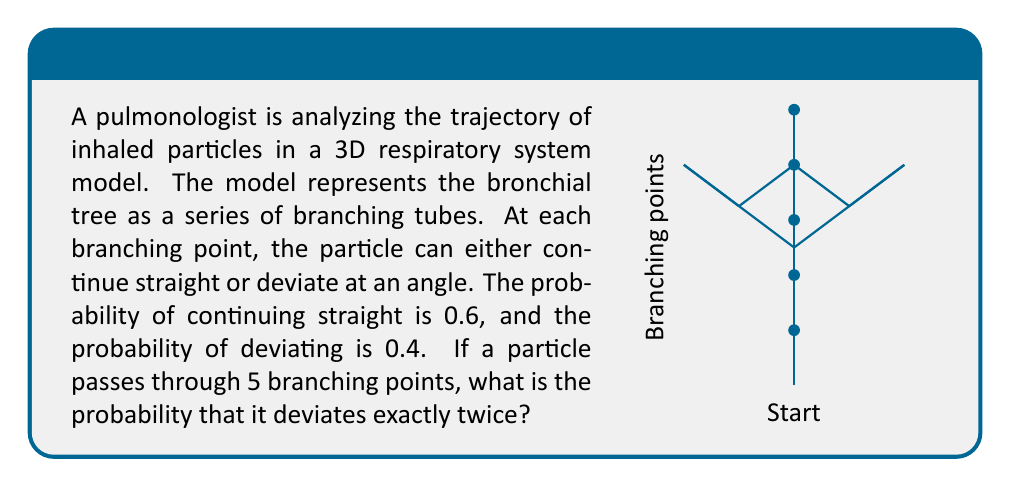Provide a solution to this math problem. To solve this problem, we'll use the concept of binomial probability. Let's break it down step-by-step:

1) We have a series of 5 independent trials (branching points), each with two possible outcomes: straight (S) or deviate (D).

2) The probability of going straight (S) at each point is $p(S) = 0.6$
   The probability of deviating (D) at each point is $p(D) = 0.4$

3) We want the probability of exactly 2 deviations out of 5 branching points.

4) This scenario follows a binomial distribution with parameters:
   $n = 5$ (number of trials)
   $k = 2$ (number of successes, where success is defined as deviation)
   $p = 0.4$ (probability of success on each trial)

5) The binomial probability formula is:

   $$P(X = k) = \binom{n}{k} p^k (1-p)^{n-k}$$

6) Substituting our values:

   $$P(X = 2) = \binom{5}{2} (0.4)^2 (0.6)^3$$

7) Calculate the binomial coefficient:
   $$\binom{5}{2} = \frac{5!}{2!(5-2)!} = \frac{5 \cdot 4}{2 \cdot 1} = 10$$

8) Now, let's compute the full expression:

   $$P(X = 2) = 10 \cdot (0.4)^2 \cdot (0.6)^3$$
   $$= 10 \cdot 0.16 \cdot 0.216$$
   $$= 0.3456$$

Therefore, the probability of the particle deviating exactly twice in 5 branching points is 0.3456 or about 34.56%.
Answer: 0.3456 